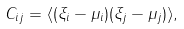<formula> <loc_0><loc_0><loc_500><loc_500>C _ { i j } = \langle ( \xi _ { i } - \mu _ { i } ) ( \xi _ { j } - \mu _ { j } ) \rangle ,</formula> 